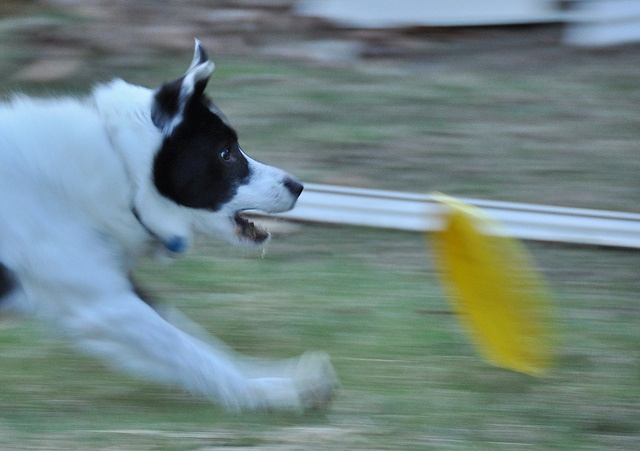Describe the objects in this image and their specific colors. I can see dog in gray, lightblue, and black tones and frisbee in gray and olive tones in this image. 